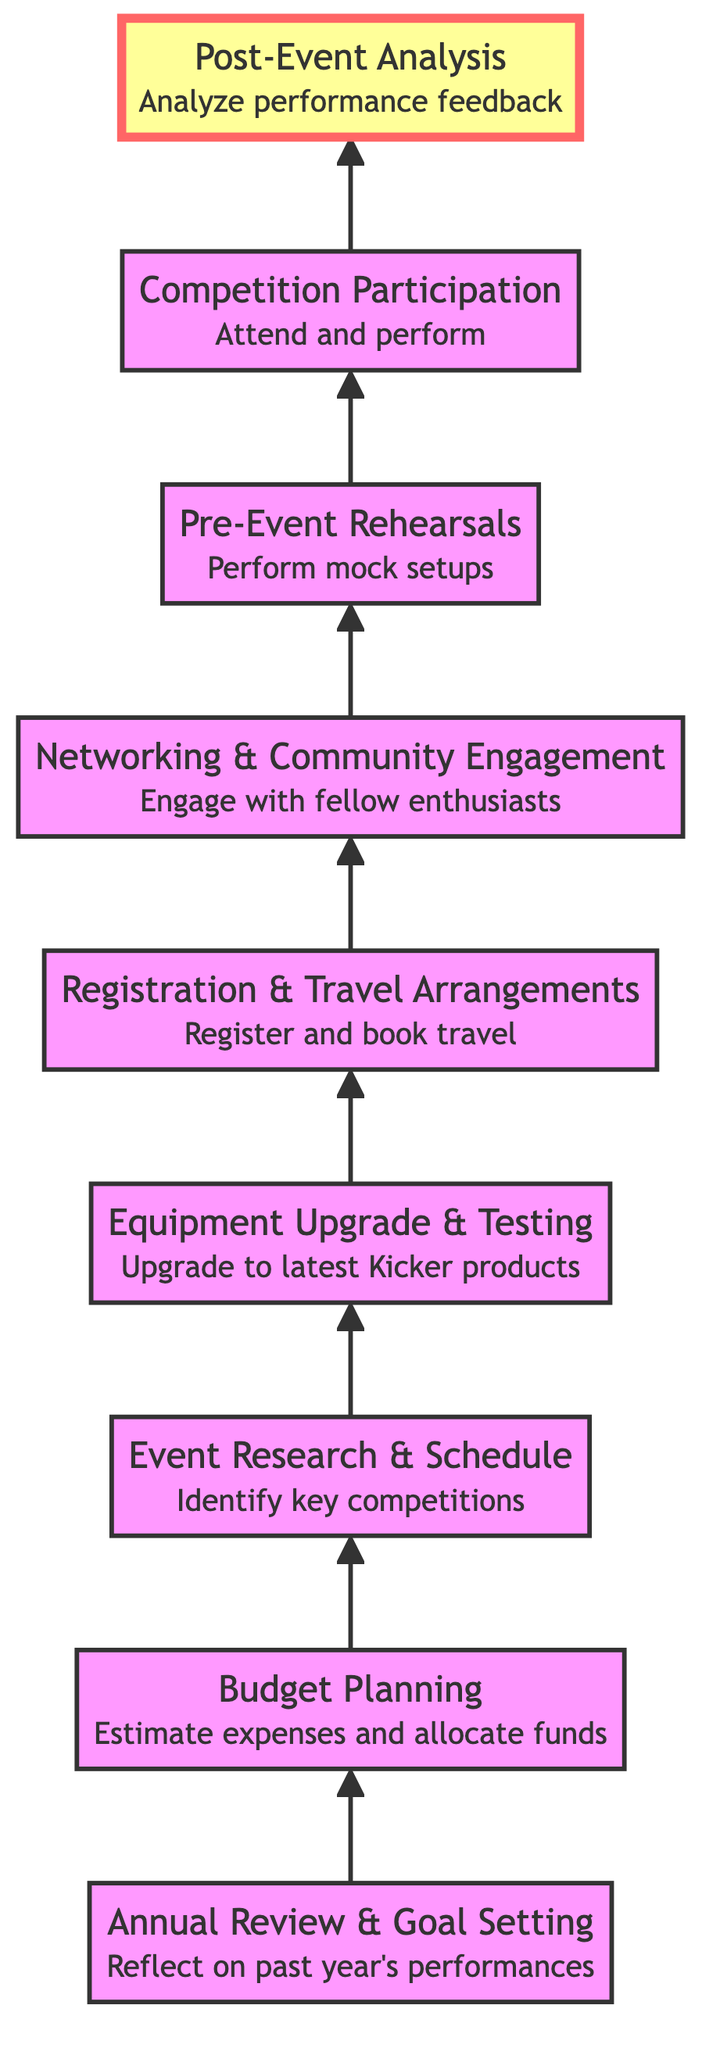What is the first step in the diagram? The first step at the bottom of the diagram is "Annual Review & Goal Setting," which is the starting point of the process.
Answer: Annual Review & Goal Setting How many nodes are present in the diagram? The diagram consists of 9 nodes, which represent different steps in the annual plan for car audio competitions.
Answer: 9 Which step comes after "Budget Planning"? Following "Budget Planning," the next step in the flow is "Event Research & Schedule." This shows the sequence of activities after budgeting.
Answer: Event Research & Schedule What is the last step in the flowchart? The last step at the top of the diagram is "Post-Event Analysis," indicating this is the concluding activity after participating in competitions.
Answer: Post-Event Analysis What relationship exists between "Competition Participation" and "Pre-Event Rehearsals"? "Competition Participation" follows directly after "Pre-Event Rehearsals," indicating that rehearsals prepare participants for the actual competition.
Answer: Directly follows Which two activities are involved before "Equipment Upgrade & Testing"? Before reaching "Equipment Upgrade & Testing," the activities are "Event Research & Schedule" and "Budget Planning," which set the groundwork for equipment improvements.
Answer: Budget Planning and Event Research & Schedule Is "Networking & Community Engagement" the only step between "Registration & Travel Arrangements" and "Pre-Event Rehearsals"? Yes, "Networking & Community Engagement" is the sole step that lies between "Registration & Travel Arrangements" and "Pre-Event Rehearsals," reflecting its place in the sequence.
Answer: Yes What is the significance of the "Post-Event Analysis" step in this context? "Post-Event Analysis" holds significance as it involves evaluating the performance feedback and results, thus serving as a reflection for future improvements.
Answer: Evaluating performance feedback What is the highest node in the diagram? The highest node, which signifies the conclusion of the flow, is "Post-Event Analysis," showing it wraps up the entire process after competition participation.
Answer: Post-Event Analysis 